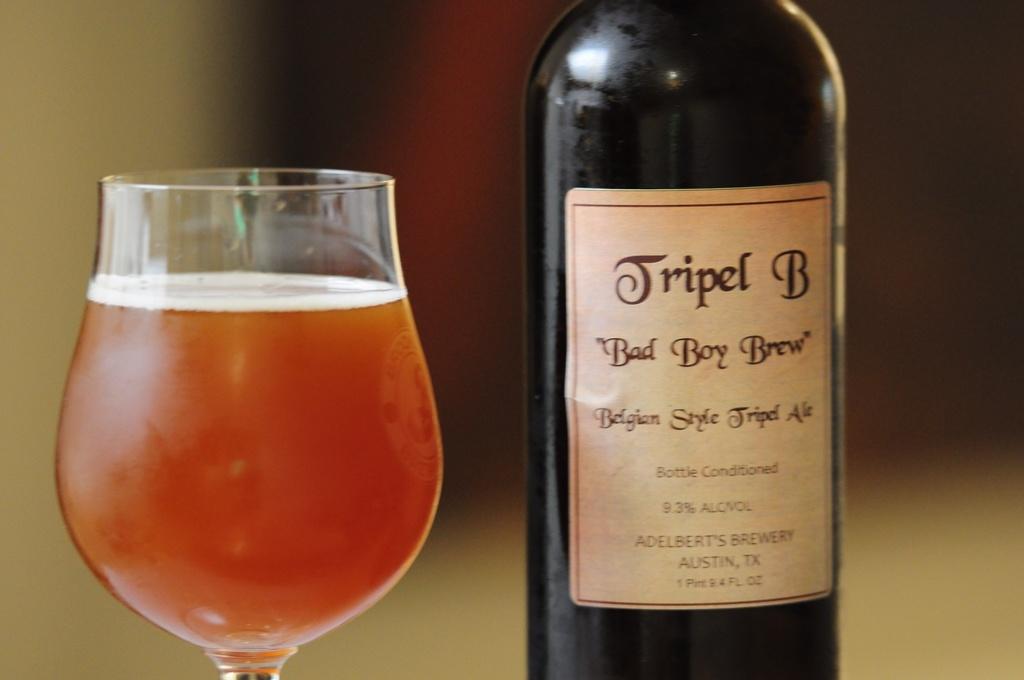What is the name of the beer?
Provide a succinct answer. Bad boy brew. 